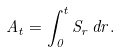Convert formula to latex. <formula><loc_0><loc_0><loc_500><loc_500>A _ { t } = \int _ { 0 } ^ { t } S _ { r } \, d r .</formula> 